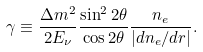<formula> <loc_0><loc_0><loc_500><loc_500>\gamma \equiv \frac { \Delta m ^ { 2 } } { 2 E _ { \nu } } \frac { \sin ^ { 2 } { 2 \theta } } { \cos { 2 \theta } } \frac { n _ { e } } { \left | d n _ { e } / d r \right | } .</formula> 